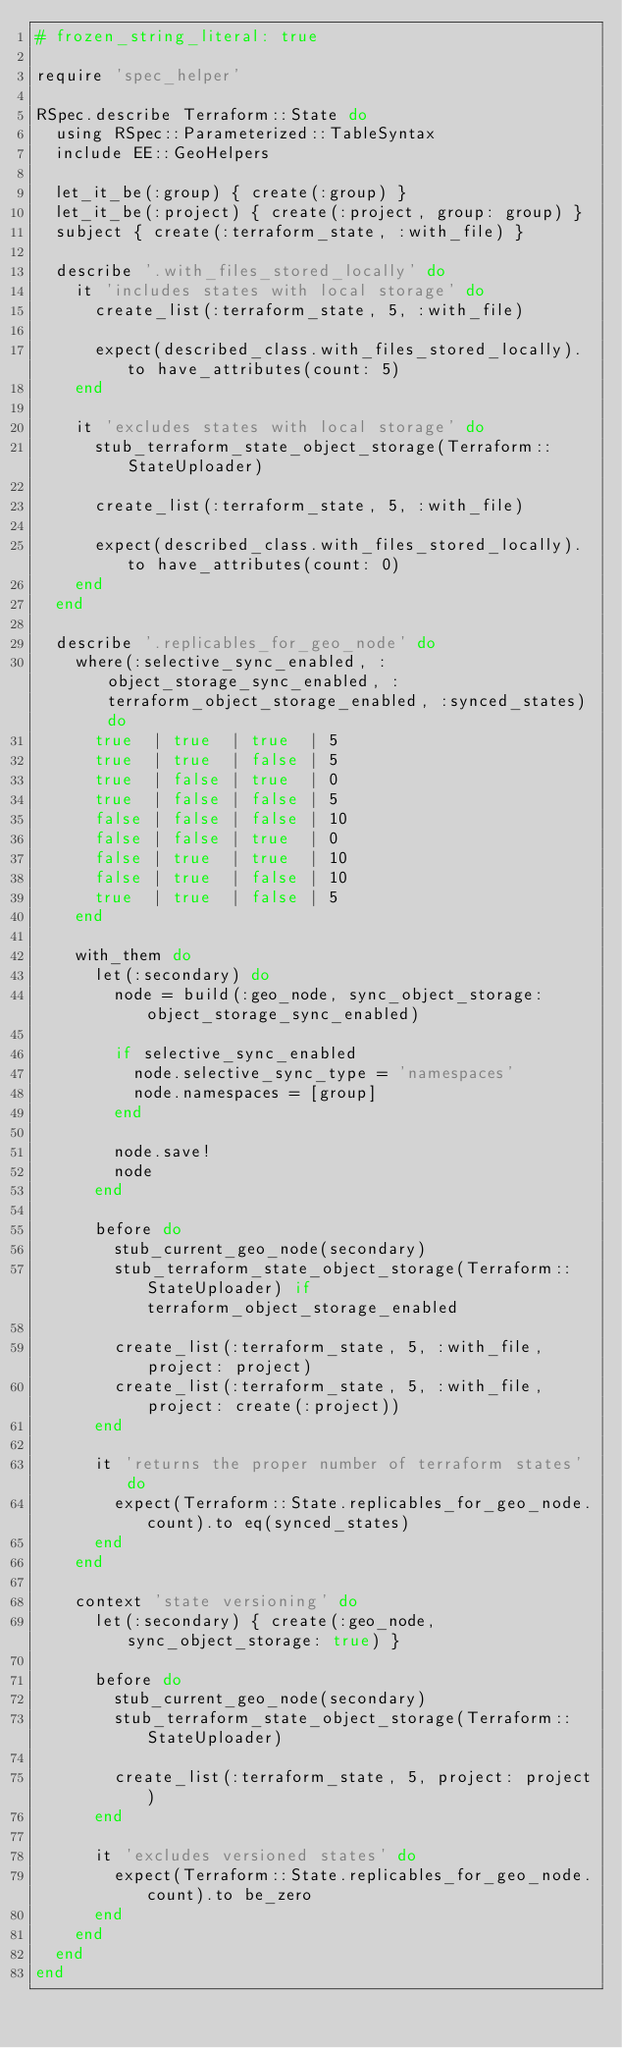<code> <loc_0><loc_0><loc_500><loc_500><_Ruby_># frozen_string_literal: true

require 'spec_helper'

RSpec.describe Terraform::State do
  using RSpec::Parameterized::TableSyntax
  include EE::GeoHelpers

  let_it_be(:group) { create(:group) }
  let_it_be(:project) { create(:project, group: group) }
  subject { create(:terraform_state, :with_file) }

  describe '.with_files_stored_locally' do
    it 'includes states with local storage' do
      create_list(:terraform_state, 5, :with_file)

      expect(described_class.with_files_stored_locally).to have_attributes(count: 5)
    end

    it 'excludes states with local storage' do
      stub_terraform_state_object_storage(Terraform::StateUploader)

      create_list(:terraform_state, 5, :with_file)

      expect(described_class.with_files_stored_locally).to have_attributes(count: 0)
    end
  end

  describe '.replicables_for_geo_node' do
    where(:selective_sync_enabled, :object_storage_sync_enabled, :terraform_object_storage_enabled, :synced_states) do
      true  | true  | true  | 5
      true  | true  | false | 5
      true  | false | true  | 0
      true  | false | false | 5
      false | false | false | 10
      false | false | true  | 0
      false | true  | true  | 10
      false | true  | false | 10
      true  | true  | false | 5
    end

    with_them do
      let(:secondary) do
        node = build(:geo_node, sync_object_storage: object_storage_sync_enabled)

        if selective_sync_enabled
          node.selective_sync_type = 'namespaces'
          node.namespaces = [group]
        end

        node.save!
        node
      end

      before do
        stub_current_geo_node(secondary)
        stub_terraform_state_object_storage(Terraform::StateUploader) if terraform_object_storage_enabled

        create_list(:terraform_state, 5, :with_file, project: project)
        create_list(:terraform_state, 5, :with_file, project: create(:project))
      end

      it 'returns the proper number of terraform states' do
        expect(Terraform::State.replicables_for_geo_node.count).to eq(synced_states)
      end
    end

    context 'state versioning' do
      let(:secondary) { create(:geo_node, sync_object_storage: true) }

      before do
        stub_current_geo_node(secondary)
        stub_terraform_state_object_storage(Terraform::StateUploader)

        create_list(:terraform_state, 5, project: project)
      end

      it 'excludes versioned states' do
        expect(Terraform::State.replicables_for_geo_node.count).to be_zero
      end
    end
  end
end
</code> 